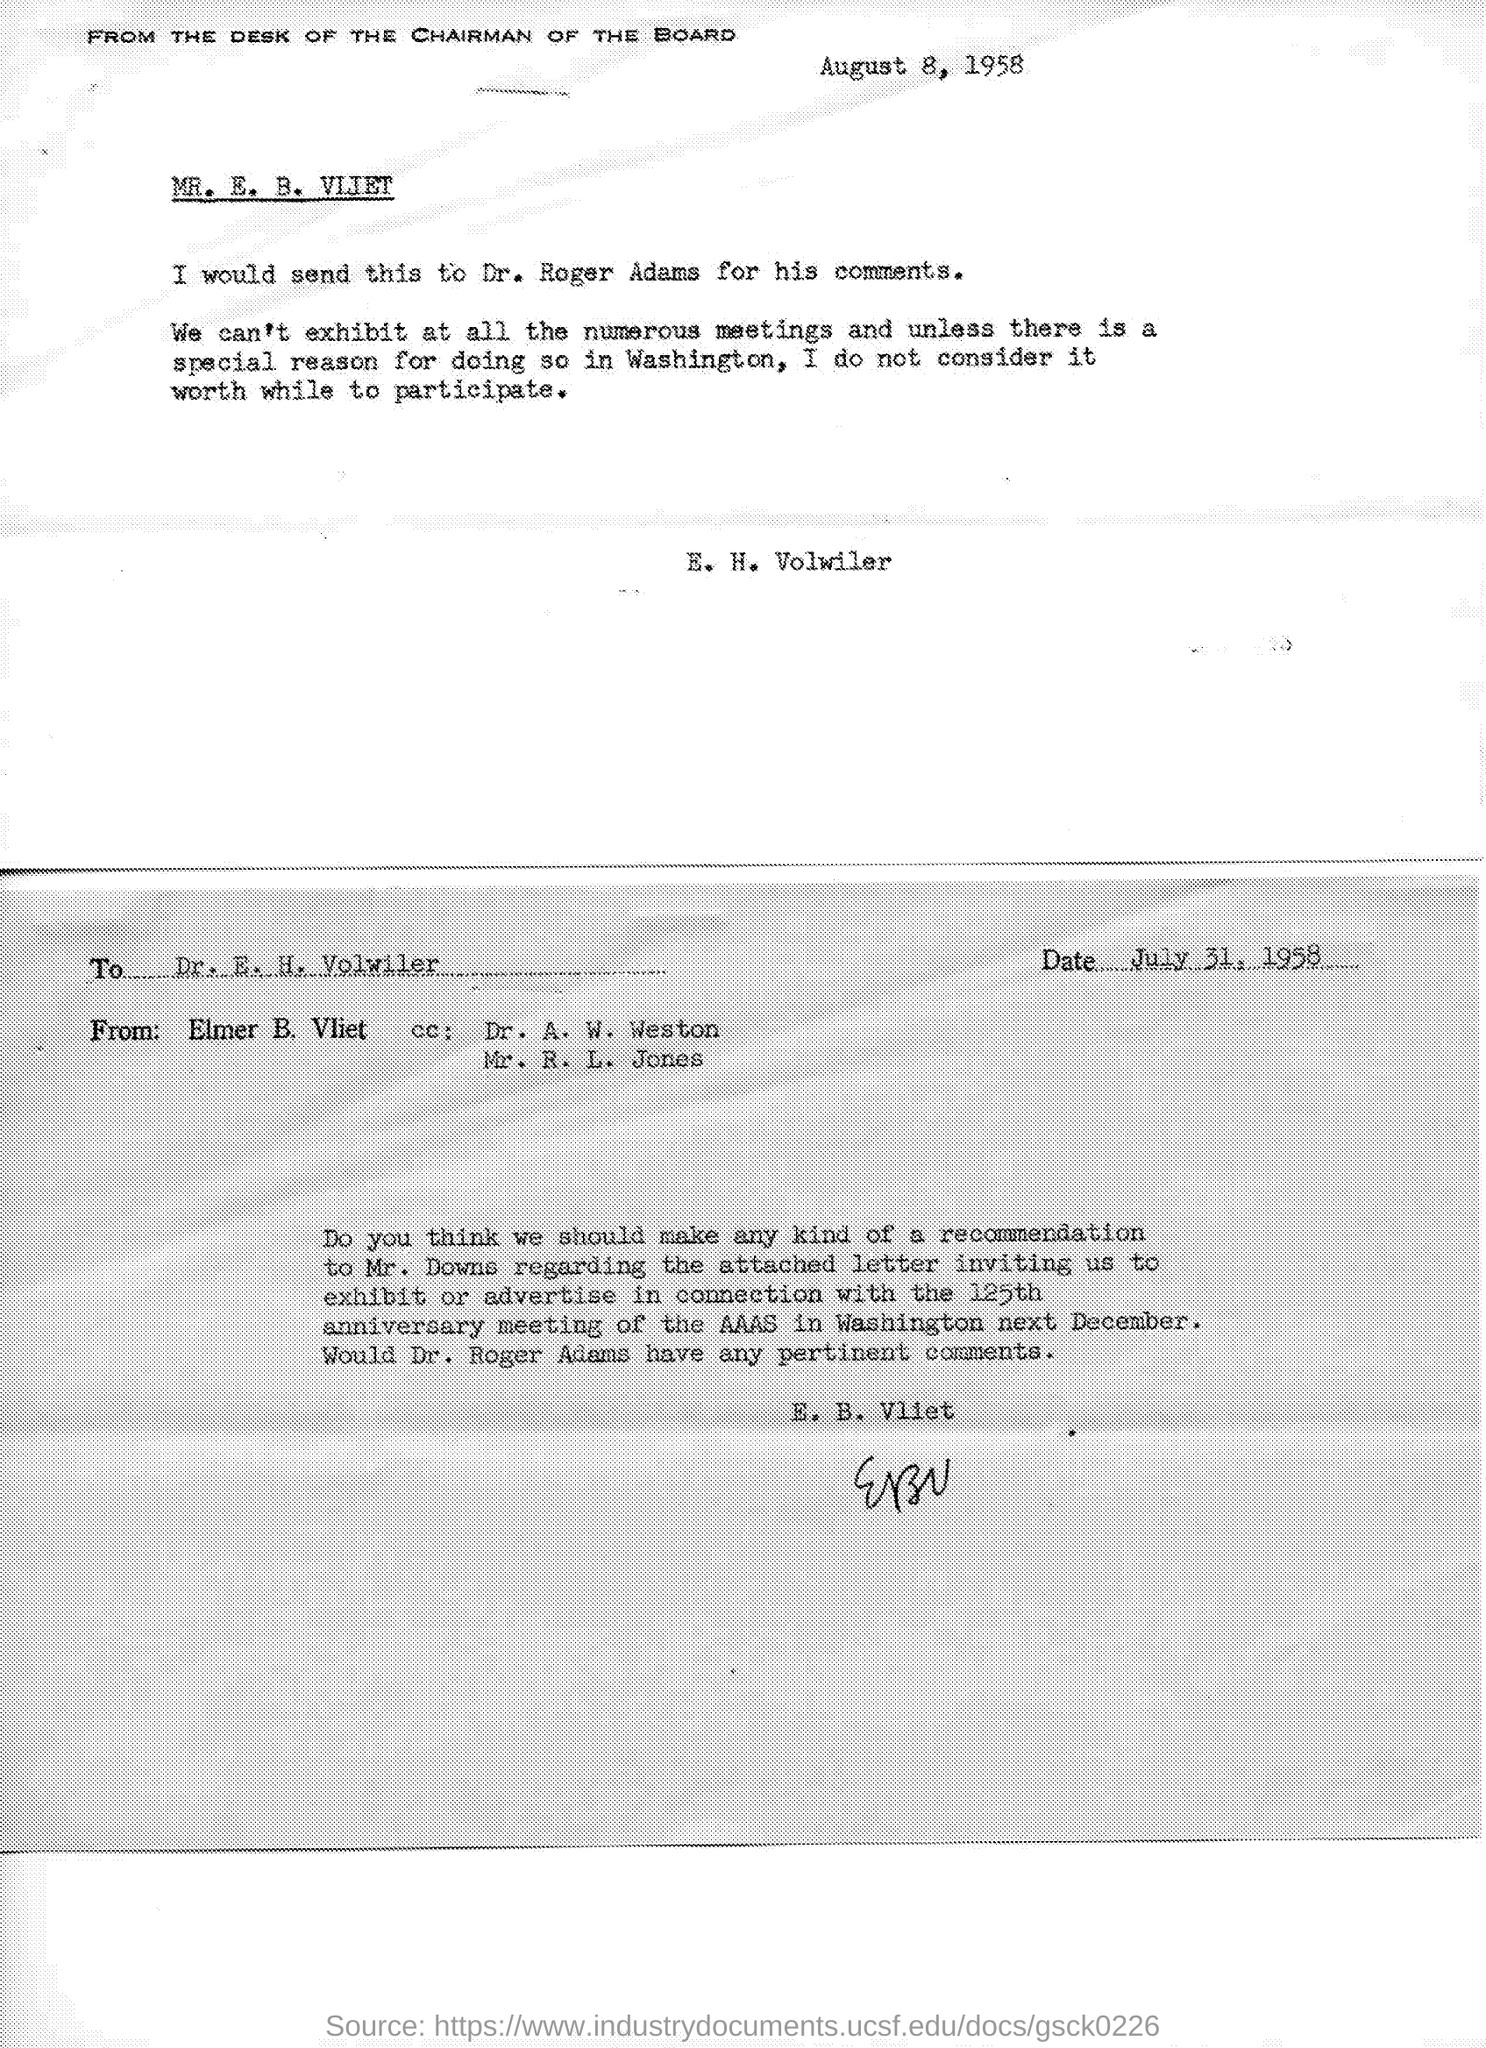What is the date on the document?
Your answer should be compact. August 8, 1958. 